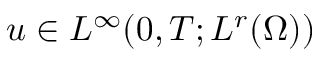Convert formula to latex. <formula><loc_0><loc_0><loc_500><loc_500>u \in L ^ { \infty } ( 0 , T ; L ^ { r } ( \Omega ) )</formula> 